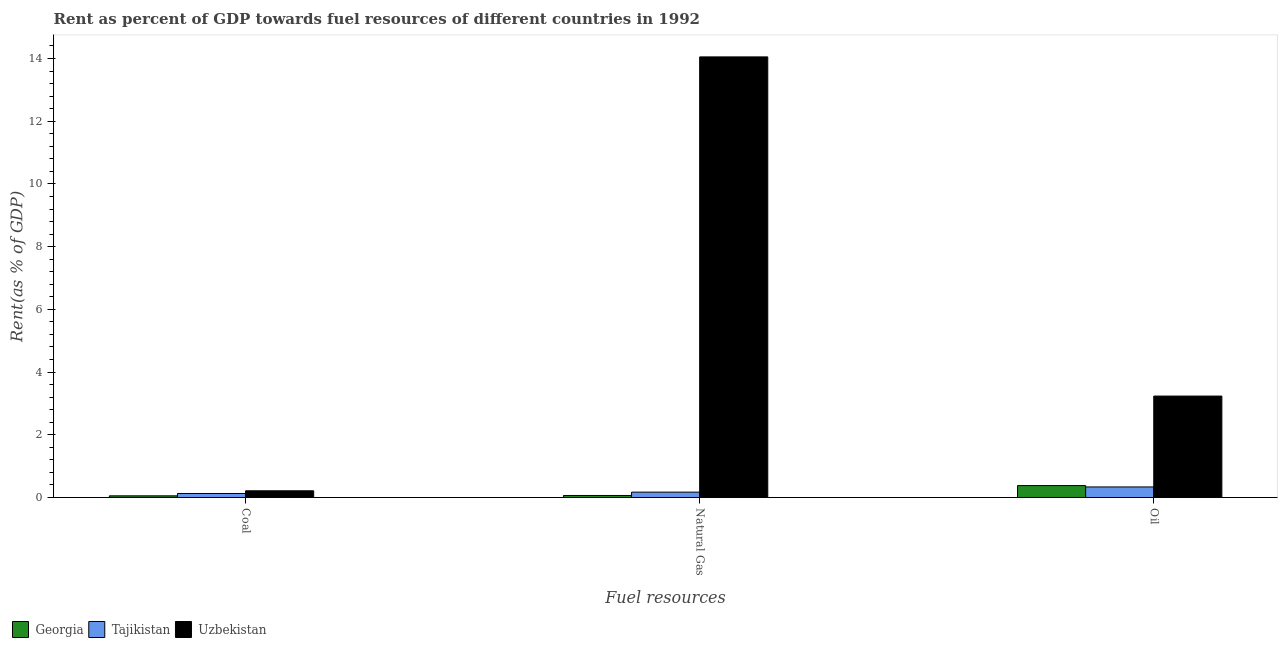How many groups of bars are there?
Your answer should be very brief. 3. Are the number of bars on each tick of the X-axis equal?
Provide a succinct answer. Yes. How many bars are there on the 1st tick from the left?
Offer a very short reply. 3. How many bars are there on the 3rd tick from the right?
Ensure brevity in your answer.  3. What is the label of the 2nd group of bars from the left?
Offer a very short reply. Natural Gas. What is the rent towards oil in Tajikistan?
Provide a succinct answer. 0.34. Across all countries, what is the maximum rent towards oil?
Provide a short and direct response. 3.23. Across all countries, what is the minimum rent towards coal?
Your response must be concise. 0.05. In which country was the rent towards coal maximum?
Offer a terse response. Uzbekistan. In which country was the rent towards natural gas minimum?
Make the answer very short. Georgia. What is the total rent towards natural gas in the graph?
Your answer should be compact. 14.29. What is the difference between the rent towards coal in Uzbekistan and that in Tajikistan?
Make the answer very short. 0.09. What is the difference between the rent towards coal in Georgia and the rent towards oil in Tajikistan?
Make the answer very short. -0.28. What is the average rent towards coal per country?
Your answer should be compact. 0.13. What is the difference between the rent towards natural gas and rent towards oil in Georgia?
Offer a terse response. -0.32. In how many countries, is the rent towards oil greater than 12.4 %?
Make the answer very short. 0. What is the ratio of the rent towards coal in Tajikistan to that in Georgia?
Your answer should be very brief. 2.41. Is the rent towards coal in Tajikistan less than that in Uzbekistan?
Offer a very short reply. Yes. What is the difference between the highest and the second highest rent towards natural gas?
Provide a short and direct response. 13.88. What is the difference between the highest and the lowest rent towards natural gas?
Provide a succinct answer. 13.99. What does the 3rd bar from the left in Oil represents?
Provide a short and direct response. Uzbekistan. What does the 3rd bar from the right in Oil represents?
Give a very brief answer. Georgia. Is it the case that in every country, the sum of the rent towards coal and rent towards natural gas is greater than the rent towards oil?
Provide a short and direct response. No. Are all the bars in the graph horizontal?
Offer a very short reply. No. How many countries are there in the graph?
Your answer should be very brief. 3. Does the graph contain grids?
Your answer should be very brief. No. Where does the legend appear in the graph?
Offer a terse response. Bottom left. How many legend labels are there?
Keep it short and to the point. 3. How are the legend labels stacked?
Keep it short and to the point. Horizontal. What is the title of the graph?
Provide a short and direct response. Rent as percent of GDP towards fuel resources of different countries in 1992. Does "New Caledonia" appear as one of the legend labels in the graph?
Your response must be concise. No. What is the label or title of the X-axis?
Ensure brevity in your answer.  Fuel resources. What is the label or title of the Y-axis?
Ensure brevity in your answer.  Rent(as % of GDP). What is the Rent(as % of GDP) in Georgia in Coal?
Provide a succinct answer. 0.05. What is the Rent(as % of GDP) of Tajikistan in Coal?
Make the answer very short. 0.13. What is the Rent(as % of GDP) in Uzbekistan in Coal?
Make the answer very short. 0.21. What is the Rent(as % of GDP) in Georgia in Natural Gas?
Ensure brevity in your answer.  0.06. What is the Rent(as % of GDP) in Tajikistan in Natural Gas?
Give a very brief answer. 0.17. What is the Rent(as % of GDP) in Uzbekistan in Natural Gas?
Your answer should be very brief. 14.05. What is the Rent(as % of GDP) of Georgia in Oil?
Make the answer very short. 0.38. What is the Rent(as % of GDP) of Tajikistan in Oil?
Keep it short and to the point. 0.34. What is the Rent(as % of GDP) in Uzbekistan in Oil?
Offer a very short reply. 3.23. Across all Fuel resources, what is the maximum Rent(as % of GDP) of Georgia?
Provide a short and direct response. 0.38. Across all Fuel resources, what is the maximum Rent(as % of GDP) of Tajikistan?
Offer a terse response. 0.34. Across all Fuel resources, what is the maximum Rent(as % of GDP) of Uzbekistan?
Ensure brevity in your answer.  14.05. Across all Fuel resources, what is the minimum Rent(as % of GDP) in Georgia?
Your answer should be very brief. 0.05. Across all Fuel resources, what is the minimum Rent(as % of GDP) in Tajikistan?
Your answer should be very brief. 0.13. Across all Fuel resources, what is the minimum Rent(as % of GDP) of Uzbekistan?
Your answer should be compact. 0.21. What is the total Rent(as % of GDP) in Georgia in the graph?
Give a very brief answer. 0.5. What is the total Rent(as % of GDP) in Tajikistan in the graph?
Make the answer very short. 0.63. What is the total Rent(as % of GDP) of Uzbekistan in the graph?
Offer a terse response. 17.5. What is the difference between the Rent(as % of GDP) of Georgia in Coal and that in Natural Gas?
Your answer should be very brief. -0.01. What is the difference between the Rent(as % of GDP) in Tajikistan in Coal and that in Natural Gas?
Ensure brevity in your answer.  -0.04. What is the difference between the Rent(as % of GDP) of Uzbekistan in Coal and that in Natural Gas?
Offer a very short reply. -13.84. What is the difference between the Rent(as % of GDP) of Georgia in Coal and that in Oil?
Your response must be concise. -0.33. What is the difference between the Rent(as % of GDP) of Tajikistan in Coal and that in Oil?
Offer a very short reply. -0.21. What is the difference between the Rent(as % of GDP) in Uzbekistan in Coal and that in Oil?
Your answer should be very brief. -3.02. What is the difference between the Rent(as % of GDP) of Georgia in Natural Gas and that in Oil?
Your response must be concise. -0.32. What is the difference between the Rent(as % of GDP) in Tajikistan in Natural Gas and that in Oil?
Offer a terse response. -0.17. What is the difference between the Rent(as % of GDP) in Uzbekistan in Natural Gas and that in Oil?
Keep it short and to the point. 10.82. What is the difference between the Rent(as % of GDP) in Georgia in Coal and the Rent(as % of GDP) in Tajikistan in Natural Gas?
Your answer should be compact. -0.12. What is the difference between the Rent(as % of GDP) of Georgia in Coal and the Rent(as % of GDP) of Uzbekistan in Natural Gas?
Provide a succinct answer. -14. What is the difference between the Rent(as % of GDP) in Tajikistan in Coal and the Rent(as % of GDP) in Uzbekistan in Natural Gas?
Keep it short and to the point. -13.92. What is the difference between the Rent(as % of GDP) of Georgia in Coal and the Rent(as % of GDP) of Tajikistan in Oil?
Your answer should be compact. -0.28. What is the difference between the Rent(as % of GDP) in Georgia in Coal and the Rent(as % of GDP) in Uzbekistan in Oil?
Keep it short and to the point. -3.18. What is the difference between the Rent(as % of GDP) in Tajikistan in Coal and the Rent(as % of GDP) in Uzbekistan in Oil?
Give a very brief answer. -3.11. What is the difference between the Rent(as % of GDP) in Georgia in Natural Gas and the Rent(as % of GDP) in Tajikistan in Oil?
Keep it short and to the point. -0.27. What is the difference between the Rent(as % of GDP) in Georgia in Natural Gas and the Rent(as % of GDP) in Uzbekistan in Oil?
Offer a very short reply. -3.17. What is the difference between the Rent(as % of GDP) in Tajikistan in Natural Gas and the Rent(as % of GDP) in Uzbekistan in Oil?
Offer a terse response. -3.06. What is the average Rent(as % of GDP) in Georgia per Fuel resources?
Offer a terse response. 0.17. What is the average Rent(as % of GDP) in Tajikistan per Fuel resources?
Make the answer very short. 0.21. What is the average Rent(as % of GDP) of Uzbekistan per Fuel resources?
Offer a very short reply. 5.83. What is the difference between the Rent(as % of GDP) of Georgia and Rent(as % of GDP) of Tajikistan in Coal?
Your answer should be very brief. -0.07. What is the difference between the Rent(as % of GDP) in Georgia and Rent(as % of GDP) in Uzbekistan in Coal?
Offer a terse response. -0.16. What is the difference between the Rent(as % of GDP) in Tajikistan and Rent(as % of GDP) in Uzbekistan in Coal?
Your answer should be compact. -0.09. What is the difference between the Rent(as % of GDP) of Georgia and Rent(as % of GDP) of Tajikistan in Natural Gas?
Offer a very short reply. -0.11. What is the difference between the Rent(as % of GDP) of Georgia and Rent(as % of GDP) of Uzbekistan in Natural Gas?
Your answer should be compact. -13.99. What is the difference between the Rent(as % of GDP) of Tajikistan and Rent(as % of GDP) of Uzbekistan in Natural Gas?
Keep it short and to the point. -13.88. What is the difference between the Rent(as % of GDP) of Georgia and Rent(as % of GDP) of Tajikistan in Oil?
Your answer should be compact. 0.04. What is the difference between the Rent(as % of GDP) of Georgia and Rent(as % of GDP) of Uzbekistan in Oil?
Offer a very short reply. -2.85. What is the difference between the Rent(as % of GDP) in Tajikistan and Rent(as % of GDP) in Uzbekistan in Oil?
Offer a terse response. -2.9. What is the ratio of the Rent(as % of GDP) in Georgia in Coal to that in Natural Gas?
Offer a terse response. 0.82. What is the ratio of the Rent(as % of GDP) in Tajikistan in Coal to that in Natural Gas?
Keep it short and to the point. 0.74. What is the ratio of the Rent(as % of GDP) of Uzbekistan in Coal to that in Natural Gas?
Provide a short and direct response. 0.02. What is the ratio of the Rent(as % of GDP) of Georgia in Coal to that in Oil?
Keep it short and to the point. 0.14. What is the ratio of the Rent(as % of GDP) of Tajikistan in Coal to that in Oil?
Offer a terse response. 0.38. What is the ratio of the Rent(as % of GDP) of Uzbekistan in Coal to that in Oil?
Provide a succinct answer. 0.07. What is the ratio of the Rent(as % of GDP) in Georgia in Natural Gas to that in Oil?
Ensure brevity in your answer.  0.17. What is the ratio of the Rent(as % of GDP) in Tajikistan in Natural Gas to that in Oil?
Your answer should be compact. 0.51. What is the ratio of the Rent(as % of GDP) of Uzbekistan in Natural Gas to that in Oil?
Your answer should be compact. 4.34. What is the difference between the highest and the second highest Rent(as % of GDP) in Georgia?
Provide a succinct answer. 0.32. What is the difference between the highest and the second highest Rent(as % of GDP) in Tajikistan?
Your answer should be compact. 0.17. What is the difference between the highest and the second highest Rent(as % of GDP) of Uzbekistan?
Make the answer very short. 10.82. What is the difference between the highest and the lowest Rent(as % of GDP) in Georgia?
Offer a very short reply. 0.33. What is the difference between the highest and the lowest Rent(as % of GDP) in Tajikistan?
Offer a very short reply. 0.21. What is the difference between the highest and the lowest Rent(as % of GDP) in Uzbekistan?
Provide a succinct answer. 13.84. 